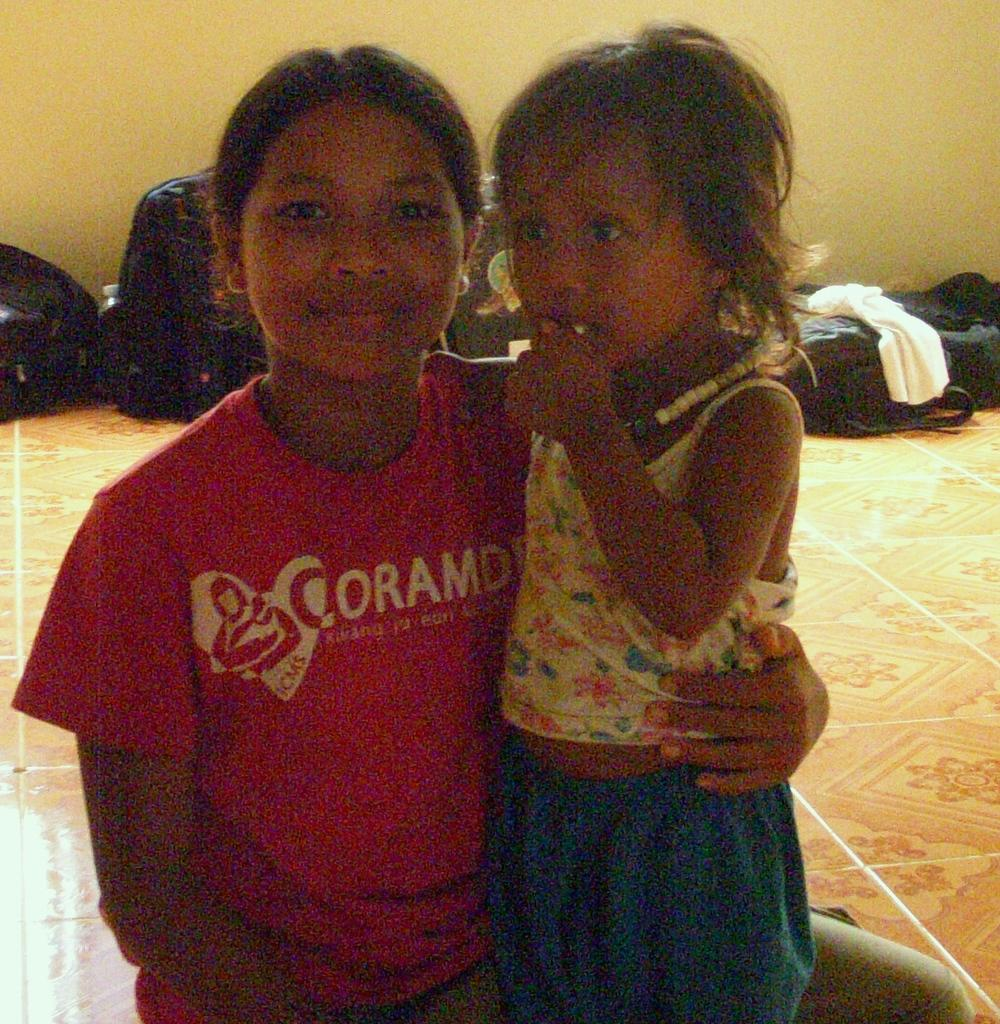How many people are in the image? There are two people in the image. What are the people doing in the image? The people are on the floor. What can be seen in the background of the image? There are bags, clothes, and a wall in the background of the image. What type of fish can be seen swimming in the office in the image? There is no fish or office present in the image; it features two people on the floor with bags, clothes, and a wall in the background. 